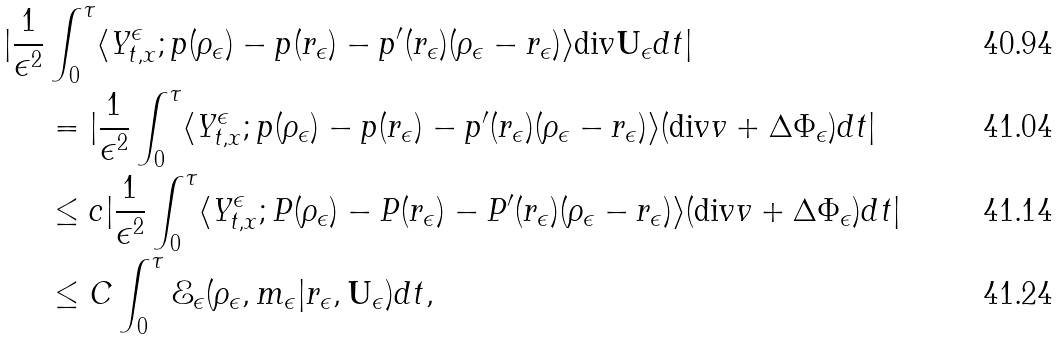Convert formula to latex. <formula><loc_0><loc_0><loc_500><loc_500>| \frac { 1 } { \epsilon ^ { 2 } } & \int ^ { \tau } _ { 0 } \langle Y ^ { \epsilon } _ { t , x } ; p ( \rho _ { \epsilon } ) - p ( r _ { \epsilon } ) - p ^ { \prime } ( r _ { \epsilon } ) ( \rho _ { \epsilon } - r _ { \epsilon } ) \rangle \text {div} \mathbf U _ { \epsilon } d t | \\ & = | \frac { 1 } { \epsilon ^ { 2 } } \int ^ { \tau } _ { 0 } \langle Y ^ { \epsilon } _ { t , x } ; p ( \rho _ { \epsilon } ) - p ( r _ { \epsilon } ) - p ^ { \prime } ( r _ { \epsilon } ) ( \rho _ { \epsilon } - r _ { \epsilon } ) \rangle ( \text {div} v + \Delta \Phi _ { \epsilon } ) d t | \\ & \leq c | \frac { 1 } { \epsilon ^ { 2 } } \int ^ { \tau } _ { 0 } \langle Y ^ { \epsilon } _ { t , x } ; P ( \rho _ { \epsilon } ) - P ( r _ { \epsilon } ) - P ^ { \prime } ( r _ { \epsilon } ) ( \rho _ { \epsilon } - r _ { \epsilon } ) \rangle ( \text {div} v + \Delta \Phi _ { \epsilon } ) d t | \\ & \leq C \int ^ { \tau } _ { 0 } \mathcal { E } _ { \epsilon } ( \rho _ { \epsilon } , m _ { \epsilon } | r _ { \epsilon } , \mathbf U _ { \epsilon } ) d t ,</formula> 